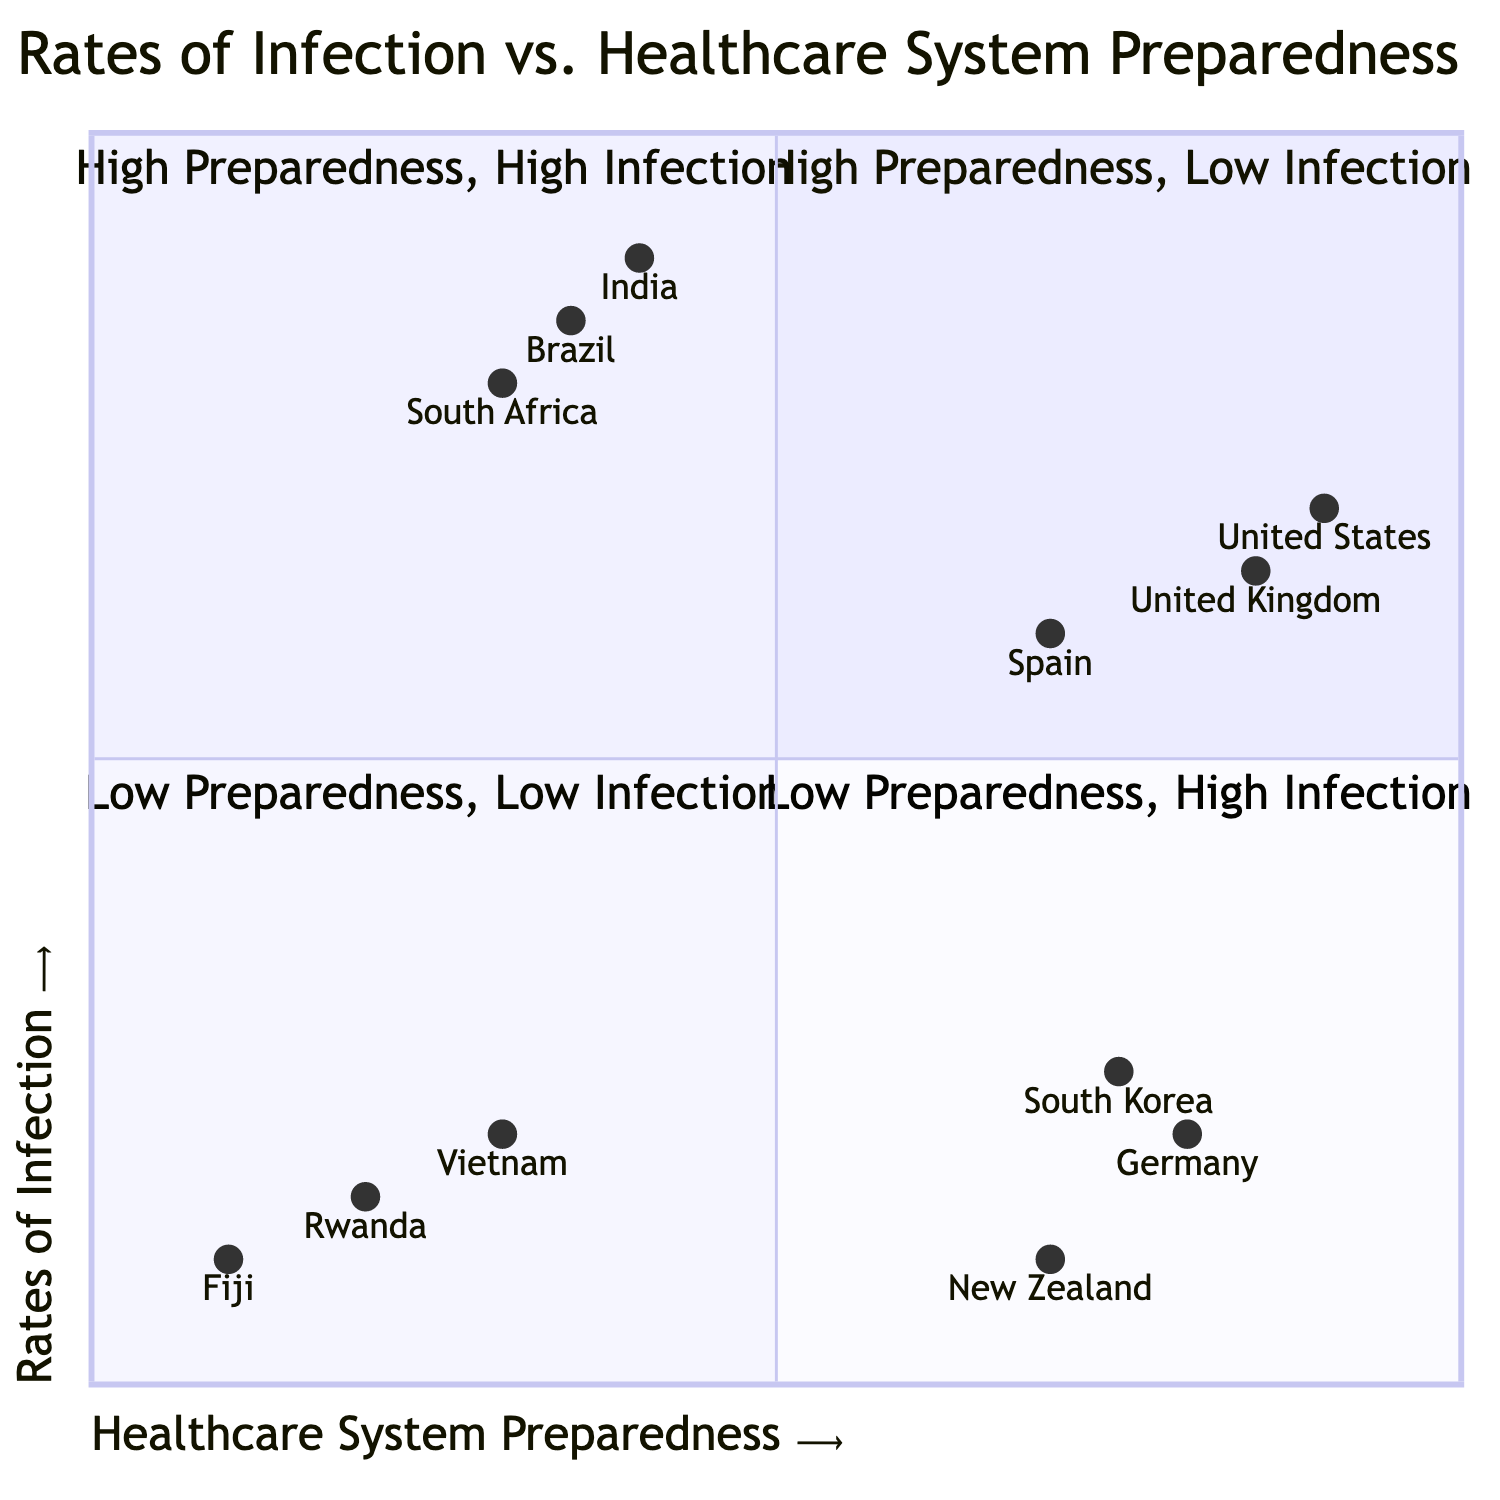What countries are found in the "High Preparedness, Low Infection" quadrant? The "High Preparedness, Low Infection" quadrant contains countries that have strong healthcare systems and low infection rates. From the provided data, the countries listed in this quadrant are Germany, South Korea, and New Zealand.
Answer: Germany, South Korea, New Zealand How many countries are in the "Low Preparedness, High Infection" quadrant? The "Low Preparedness, High Infection" quadrant consists of countries that have inadequate healthcare systems paired with high rates of infection. Based on the data, there are three countries listed in this quadrant: India, Brazil, and South Africa. The count provides the answer.
Answer: 3 What is the infection rate of Vietnam? Vietnam is positioned in the "Low Preparedness, Low Infection" quadrant, with a healthcare preparedness score of 0.3 and an infection rate of 0.2. The question specifically asks for the infection rate, which is straightforward to locate.
Answer: 0.2 Which countries have high preparedness but experience high infection rates? The quadrant titled "High Preparedness, High Infection" includes countries with strong healthcare systems yet still face high infection rates possibly due to various external factors. The countries identified in this quadrant are the United States, United Kingdom, and Spain, thus providing the answer.
Answer: United States, United Kingdom, Spain What is the healthcare preparedness score of South Africa? South Africa is categorized in the "Low Preparedness, High Infection" quadrant. Referring to the data, the healthcare preparedness score for South Africa is identified as 0.3. This score directly addresses the inquiry.
Answer: 0.3 Which quadrant contains the lowest infection rates? The "High Preparedness, Low Infection" quadrant is characterized by its members having robust healthcare systems and notably low infection rates. This description directly indicates that the lowest infection rates are found here, leading to the answer.
Answer: High Preparedness, Low Infection What is the highest rate of infection among countries in the "Low Preparedness, High Infection" quadrant? This quadrant includes countries with limited healthcare capacity where the infection rates are significant. Among the listed countries—India, Brazil, and South Africa—India has the highest infection rate at 0.9, making it the answer to the question.
Answer: 0.9 How many quadrants are represented in the chart? The diagram is categorized into four distinct quadrants that represent varying combinations of healthcare system preparedness and rates of infection. Reviewing the design, it can be confirmed that there are precisely four quadrants displayed.
Answer: 4 